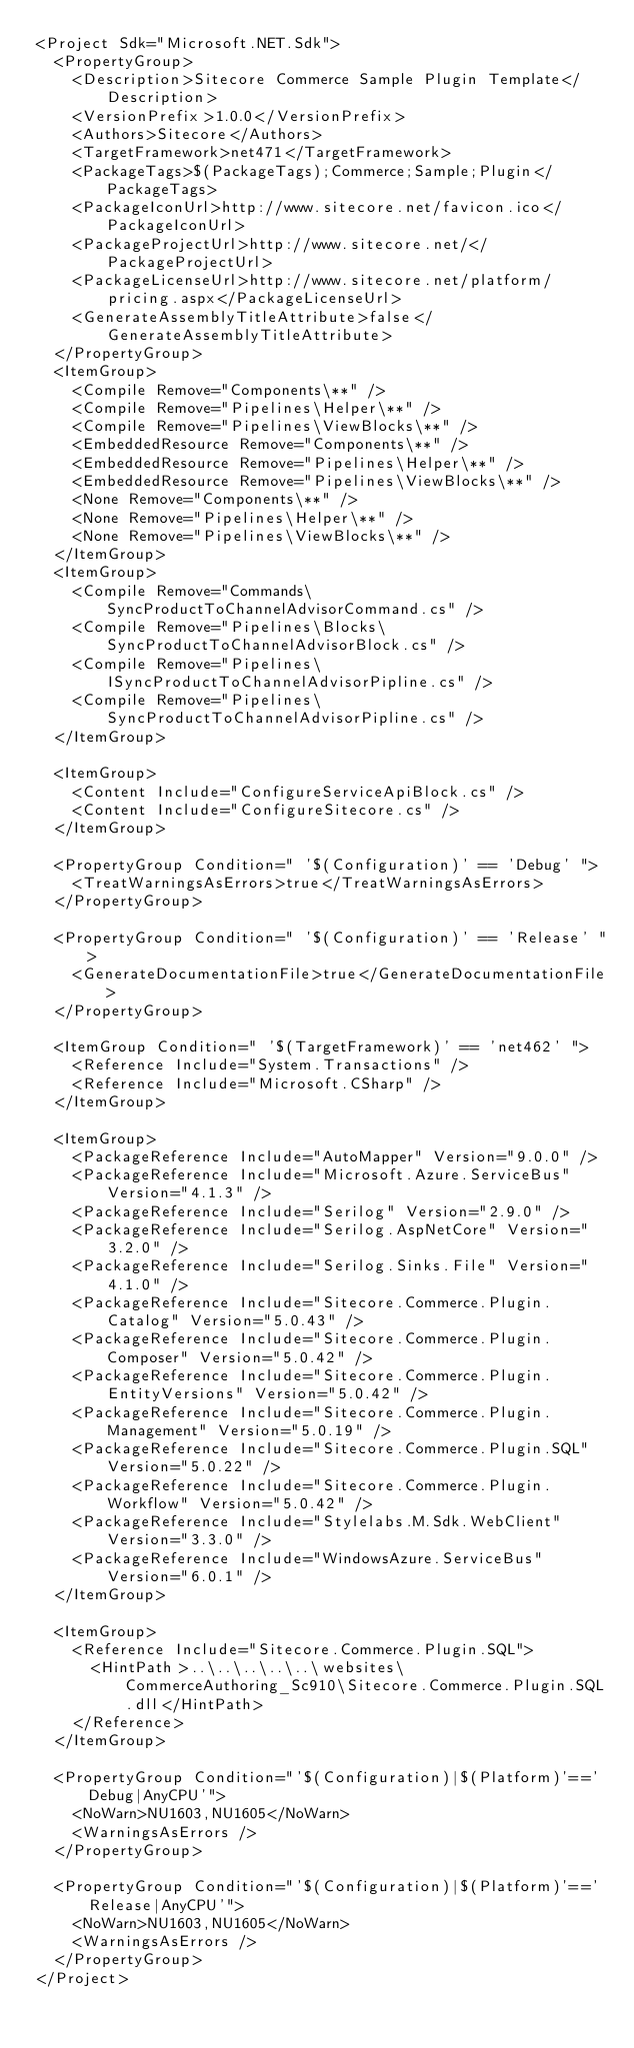<code> <loc_0><loc_0><loc_500><loc_500><_XML_><Project Sdk="Microsoft.NET.Sdk">
  <PropertyGroup>
    <Description>Sitecore Commerce Sample Plugin Template</Description>
    <VersionPrefix>1.0.0</VersionPrefix>
    <Authors>Sitecore</Authors>
    <TargetFramework>net471</TargetFramework>
    <PackageTags>$(PackageTags);Commerce;Sample;Plugin</PackageTags>
    <PackageIconUrl>http://www.sitecore.net/favicon.ico</PackageIconUrl>
    <PackageProjectUrl>http://www.sitecore.net/</PackageProjectUrl>
    <PackageLicenseUrl>http://www.sitecore.net/platform/pricing.aspx</PackageLicenseUrl>
    <GenerateAssemblyTitleAttribute>false</GenerateAssemblyTitleAttribute>
  </PropertyGroup>
  <ItemGroup>
    <Compile Remove="Components\**" />
    <Compile Remove="Pipelines\Helper\**" />
    <Compile Remove="Pipelines\ViewBlocks\**" />
    <EmbeddedResource Remove="Components\**" />
    <EmbeddedResource Remove="Pipelines\Helper\**" />
    <EmbeddedResource Remove="Pipelines\ViewBlocks\**" />
    <None Remove="Components\**" />
    <None Remove="Pipelines\Helper\**" />
    <None Remove="Pipelines\ViewBlocks\**" />
  </ItemGroup>
  <ItemGroup>
    <Compile Remove="Commands\SyncProductToChannelAdvisorCommand.cs" />
    <Compile Remove="Pipelines\Blocks\SyncProductToChannelAdvisorBlock.cs" />
    <Compile Remove="Pipelines\ISyncProductToChannelAdvisorPipline.cs" />
    <Compile Remove="Pipelines\SyncProductToChannelAdvisorPipline.cs" />
  </ItemGroup>

  <ItemGroup>
    <Content Include="ConfigureServiceApiBlock.cs" />
    <Content Include="ConfigureSitecore.cs" />
  </ItemGroup>

  <PropertyGroup Condition=" '$(Configuration)' == 'Debug' ">
    <TreatWarningsAsErrors>true</TreatWarningsAsErrors>
  </PropertyGroup>

  <PropertyGroup Condition=" '$(Configuration)' == 'Release' ">
    <GenerateDocumentationFile>true</GenerateDocumentationFile>
  </PropertyGroup>

  <ItemGroup Condition=" '$(TargetFramework)' == 'net462' ">
    <Reference Include="System.Transactions" />
    <Reference Include="Microsoft.CSharp" />
  </ItemGroup>

  <ItemGroup>
    <PackageReference Include="AutoMapper" Version="9.0.0" />
    <PackageReference Include="Microsoft.Azure.ServiceBus" Version="4.1.3" />
    <PackageReference Include="Serilog" Version="2.9.0" />
    <PackageReference Include="Serilog.AspNetCore" Version="3.2.0" />
    <PackageReference Include="Serilog.Sinks.File" Version="4.1.0" />
    <PackageReference Include="Sitecore.Commerce.Plugin.Catalog" Version="5.0.43" />
    <PackageReference Include="Sitecore.Commerce.Plugin.Composer" Version="5.0.42" />
    <PackageReference Include="Sitecore.Commerce.Plugin.EntityVersions" Version="5.0.42" />
    <PackageReference Include="Sitecore.Commerce.Plugin.Management" Version="5.0.19" />
    <PackageReference Include="Sitecore.Commerce.Plugin.SQL" Version="5.0.22" />
    <PackageReference Include="Sitecore.Commerce.Plugin.Workflow" Version="5.0.42" />
    <PackageReference Include="Stylelabs.M.Sdk.WebClient" Version="3.3.0" />
    <PackageReference Include="WindowsAzure.ServiceBus" Version="6.0.1" />
  </ItemGroup>

  <ItemGroup>
    <Reference Include="Sitecore.Commerce.Plugin.SQL">
      <HintPath>..\..\..\..\..\websites\CommerceAuthoring_Sc910\Sitecore.Commerce.Plugin.SQL.dll</HintPath>
    </Reference>
  </ItemGroup>

  <PropertyGroup Condition="'$(Configuration)|$(Platform)'=='Debug|AnyCPU'">
    <NoWarn>NU1603,NU1605</NoWarn>
    <WarningsAsErrors />
  </PropertyGroup>

  <PropertyGroup Condition="'$(Configuration)|$(Platform)'=='Release|AnyCPU'">
    <NoWarn>NU1603,NU1605</NoWarn>
    <WarningsAsErrors />
  </PropertyGroup>
</Project>
</code> 